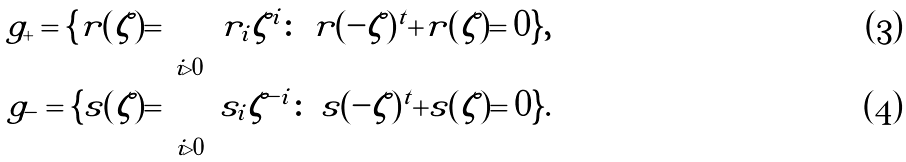Convert formula to latex. <formula><loc_0><loc_0><loc_500><loc_500>\ g _ { + } = \{ r ( \zeta ) = \sum _ { i > 0 } r _ { i } \zeta ^ { i } \colon \ r ( - \zeta ) ^ { t } + r ( \zeta ) = 0 \} , \\ \ g _ { - } = \{ s ( \zeta ) = \sum _ { i > 0 } s _ { i } \zeta ^ { - i } \colon \ s ( - \zeta ) ^ { t } + s ( \zeta ) = 0 \} .</formula> 